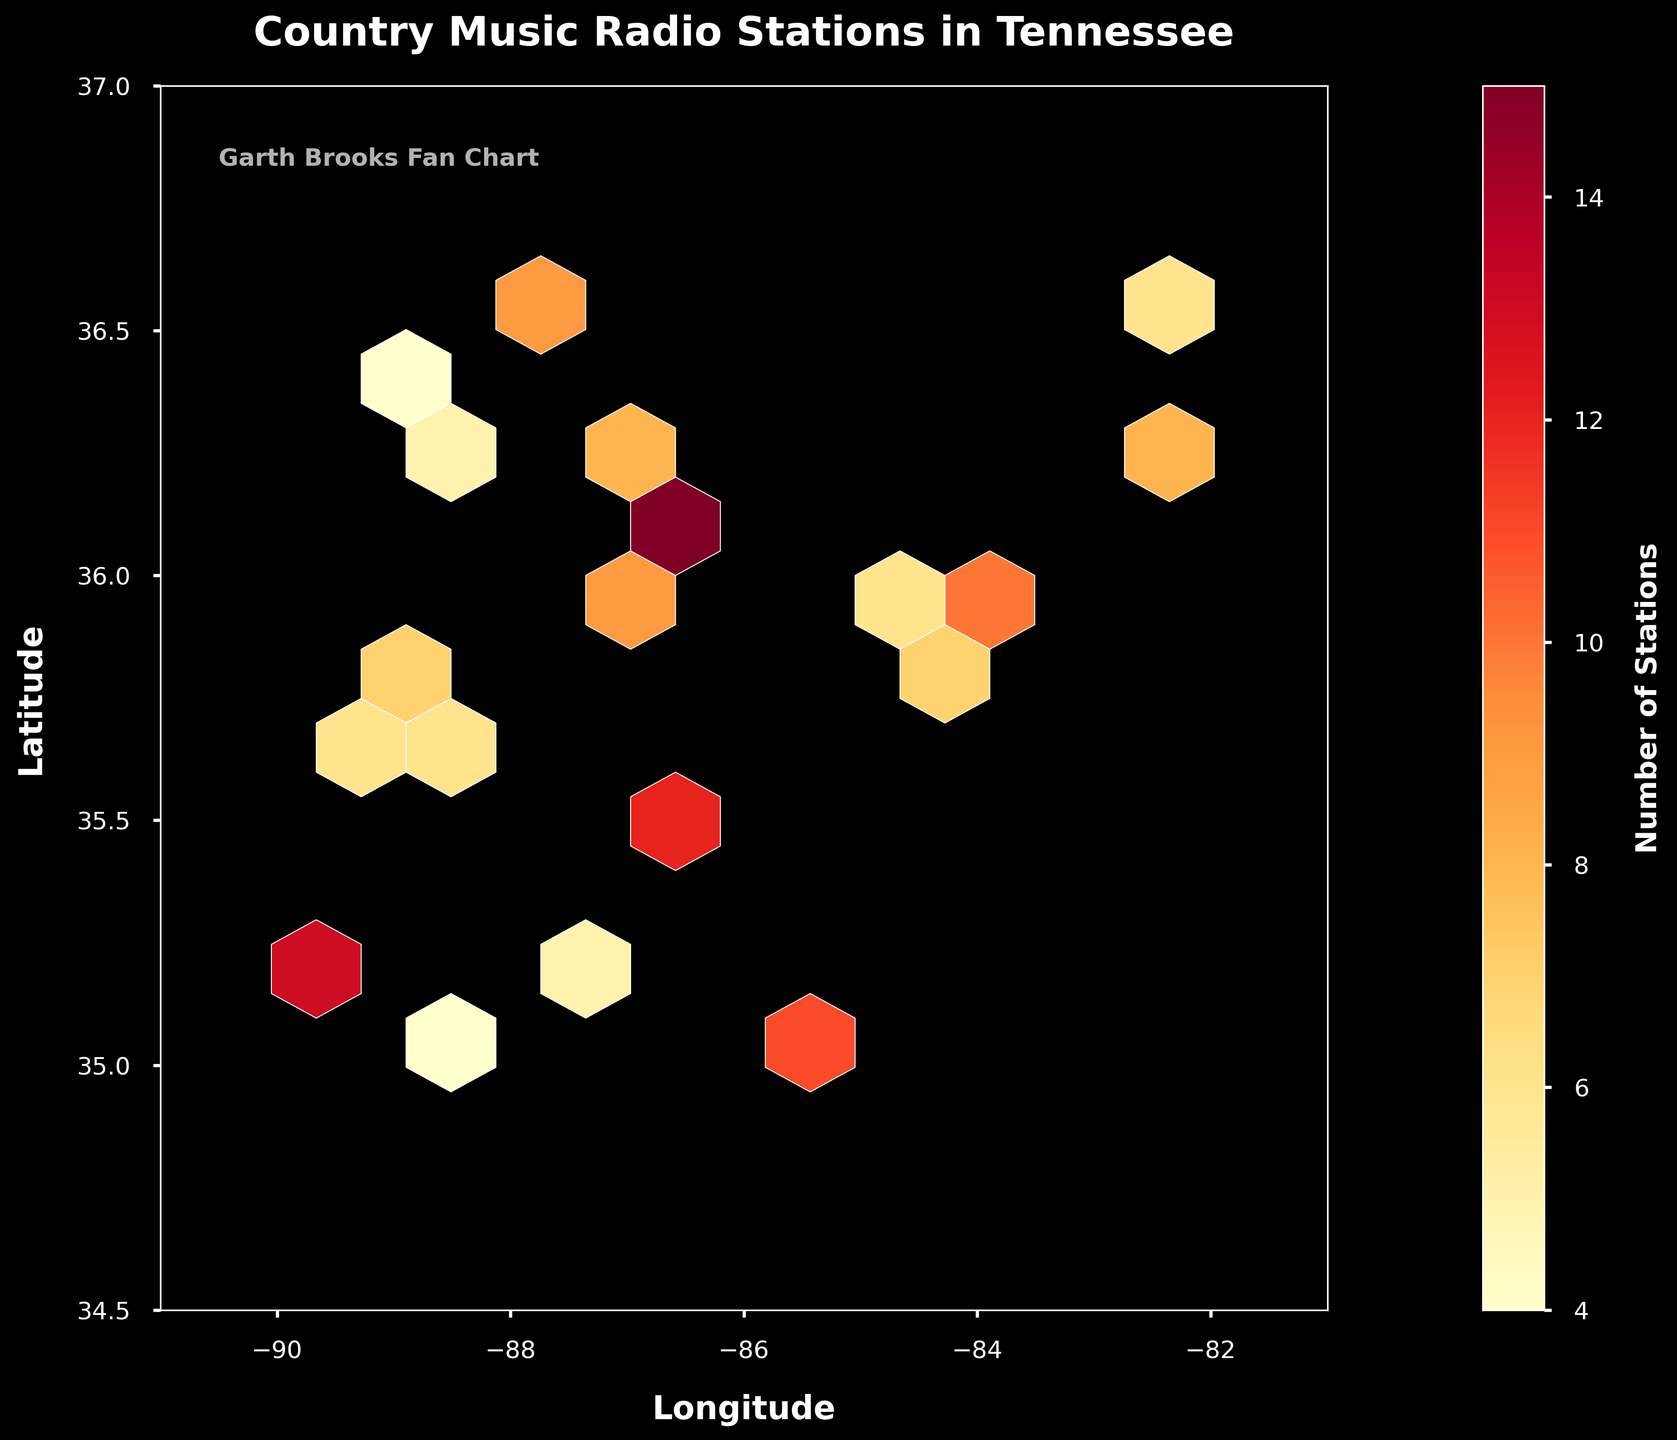What's the title of the figure? The title of the figure is typically placed at the top of the chart in a larger font size. It acts as a quick summary of what the chart is about. In this case, it reads "Country Music Radio Stations in Tennessee."
Answer: Country Music Radio Stations in Tennessee What variable does the color represent in this Hexbin plot? In a Hexbin plot, colors often represent a certain numerical value associated with the data points within each hexagonal bin. Here, the color represents the "Number of Stations," as indicated by the color bar on the side.
Answer: Number of Stations Which area of Tennessee has the highest concentration of country music radio stations according to the plot? To identify the area with the highest concentration, look for the hexagons in the plot with the most intense colors, often towards the upper range of the colormap. The Nashville area, centered around the coordinates (36.1628, -86.7816), shows the highest concentration.
Answer: Nashville area What do the x-axis and y-axis represent? In the plot, the x-axis is labeled "Longitude," and the y-axis is labeled "Latitude." These axes represent the geographical coordinates of country music radio stations in Tennessee.
Answer: Longitude and Latitude How many different color levels are used to represent the number of stations? Looking at the color bar, you can count the distinct color segments that indicate ranges for the number of stations. Typically, around 5 to 7 levels might be used in such colormaps.
Answer: Around 6 What is the range of station counts displayed by the color gradient in the plot? The color gradient on the color bar represents the range of station counts. Check the numerical values alongside the color bar to see the lower and upper limits, which ranges from approximately 4 to 15.
Answer: 4 to 15 Does the plot indicate any specific area with fewer country music radio stations? Areas with lighter colors or lesser intensity in the hexagons indicate sparse stations. The regions around the coordinates (35.0867, -88.2390) and (36.4134, -89.0687) show fewer stations.
Answer: Yes, around 35.0867, -88.2390 and 36.4134, -89.0687 Comparatively, does Memphis or Knoxville have more country music radio stations? Memphis is represented around the coordinates (35.1495, -90.0490) and Knoxville around (35.9606, -83.9207). By comparing the color intensities and referring to the color bar, Memphis has slightly more stations than Knoxville.
Answer: Memphis What does the text inside the plot indicate? The text within the plot reads "Garth Brooks Fan Chart." It is a personalized touch, indicating that the chart was made by a fan of Garth Brooks. It doesn't affect the data but adds a personal element.
Answer: Garth Brooks Fan Chart What hexbin gridsize is used in the plot and why is this important? The hexbin `gridsize=10` as seen in the code, is important because it controls the granularity of the bins. A smaller grid size would result in more but smaller hexagons.
Answer: 10 